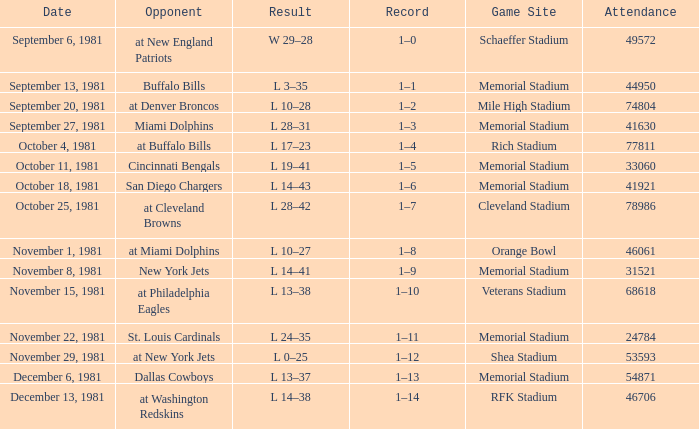On october 18, 1981, where is the location of the game? Memorial Stadium. 